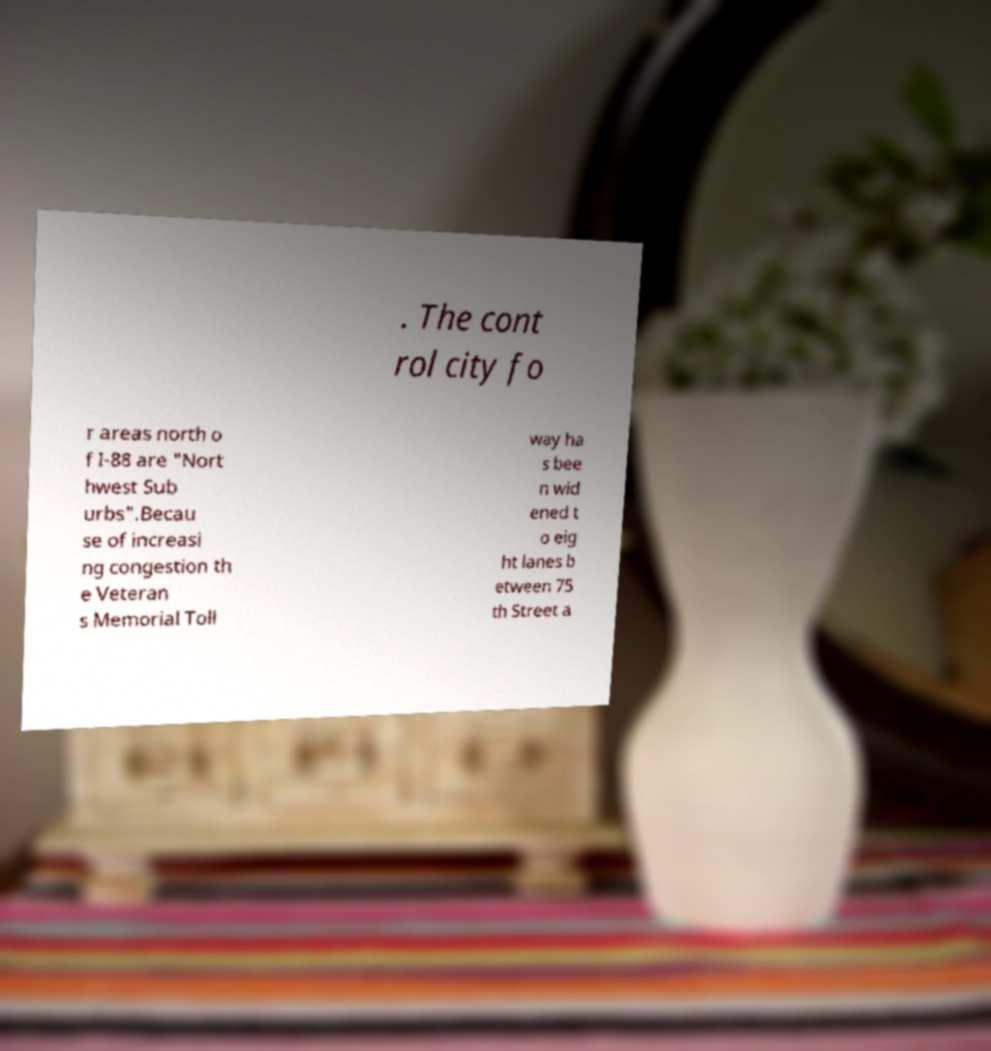Can you read and provide the text displayed in the image?This photo seems to have some interesting text. Can you extract and type it out for me? . The cont rol city fo r areas north o f I-88 are "Nort hwest Sub urbs".Becau se of increasi ng congestion th e Veteran s Memorial Toll way ha s bee n wid ened t o eig ht lanes b etween 75 th Street a 